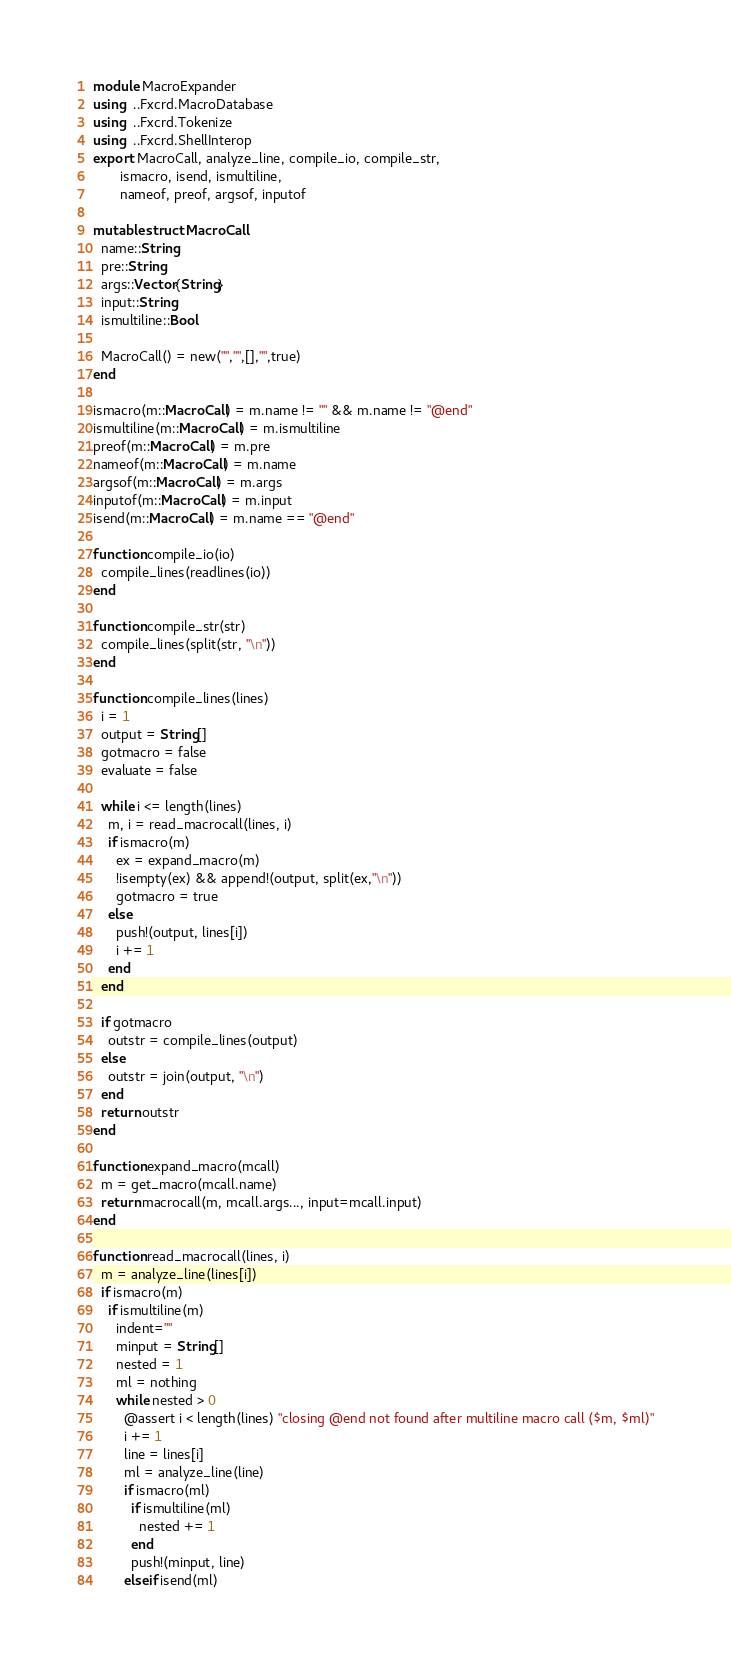<code> <loc_0><loc_0><loc_500><loc_500><_Julia_>module MacroExpander
using  ..Fxcrd.MacroDatabase
using  ..Fxcrd.Tokenize
using  ..Fxcrd.ShellInterop
export MacroCall, analyze_line, compile_io, compile_str,
       ismacro, isend, ismultiline,
       nameof, preof, argsof, inputof

mutable struct MacroCall
  name::String
  pre::String
  args::Vector{String}
  input::String
  ismultiline::Bool

  MacroCall() = new("","",[],"",true)
end

ismacro(m::MacroCall) = m.name != "" && m.name != "@end"
ismultiline(m::MacroCall) = m.ismultiline
preof(m::MacroCall) = m.pre
nameof(m::MacroCall) = m.name
argsof(m::MacroCall) = m.args
inputof(m::MacroCall) = m.input
isend(m::MacroCall) = m.name == "@end"

function compile_io(io)
  compile_lines(readlines(io))
end

function compile_str(str)
  compile_lines(split(str, "\n"))
end

function compile_lines(lines)
  i = 1
  output = String[]
  gotmacro = false
  evaluate = false

  while i <= length(lines)
    m, i = read_macrocall(lines, i)
    if ismacro(m)
      ex = expand_macro(m)
      !isempty(ex) && append!(output, split(ex,"\n"))
      gotmacro = true
    else
      push!(output, lines[i])
      i += 1
    end
  end

  if gotmacro
    outstr = compile_lines(output)
  else
    outstr = join(output, "\n")
  end
  return outstr
end

function expand_macro(mcall)
  m = get_macro(mcall.name)
  return macrocall(m, mcall.args..., input=mcall.input)
end

function read_macrocall(lines, i)
  m = analyze_line(lines[i])
  if ismacro(m)
    if ismultiline(m)
      indent=""
      minput = String[]
      nested = 1
      ml = nothing
      while nested > 0
        @assert i < length(lines) "closing @end not found after multiline macro call ($m, $ml)"
        i += 1
        line = lines[i]
        ml = analyze_line(line)
        if ismacro(ml)
          if ismultiline(ml)
            nested += 1
          end
          push!(minput, line)
        elseif isend(ml)</code> 